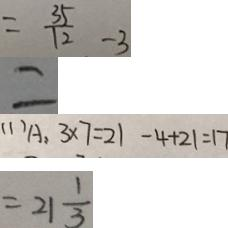Convert formula to latex. <formula><loc_0><loc_0><loc_500><loc_500>= \frac { 3 5 } { 1 2 } - 3 
 = 
 ( 1 ) A : 3 \times 7 = 2 1 - 4 + 2 1 = 1 7 
 = 2 1 \frac { 1 } { 3 }</formula> 